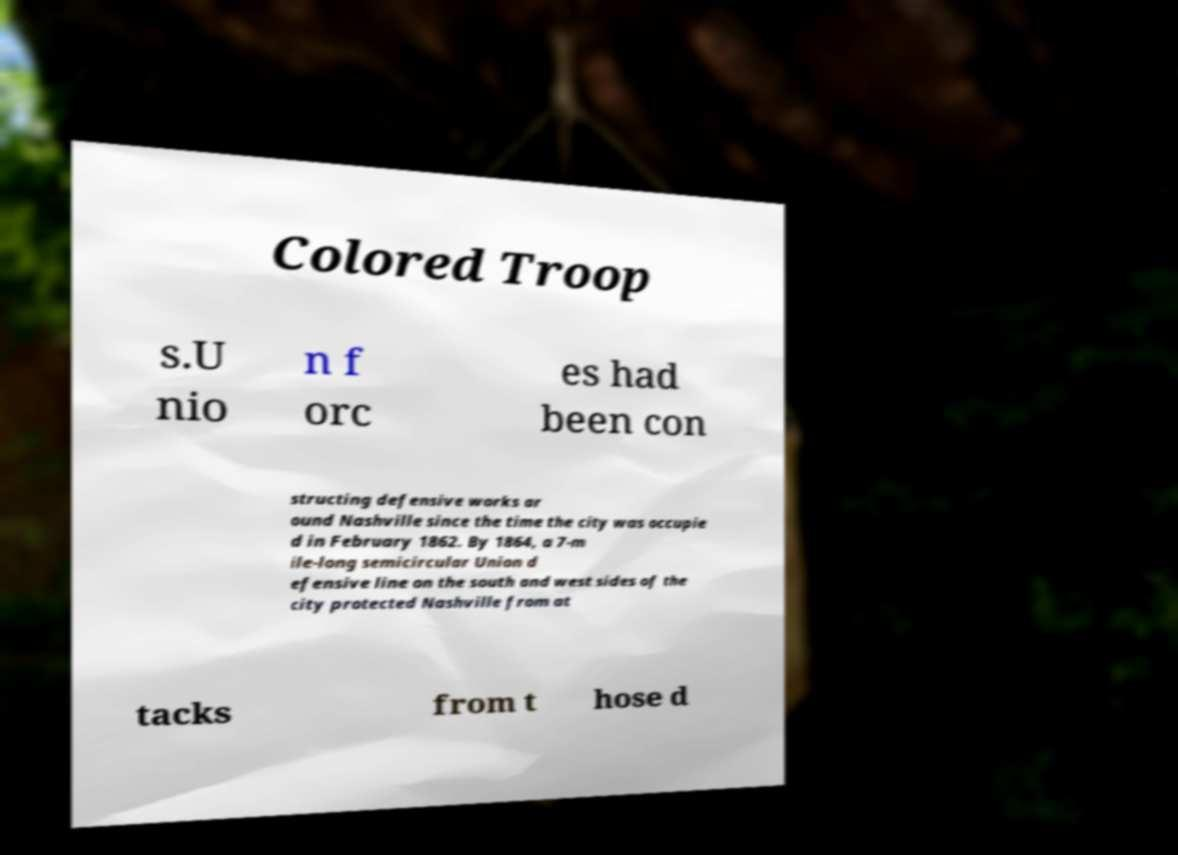Can you read and provide the text displayed in the image?This photo seems to have some interesting text. Can you extract and type it out for me? Colored Troop s.U nio n f orc es had been con structing defensive works ar ound Nashville since the time the city was occupie d in February 1862. By 1864, a 7-m ile-long semicircular Union d efensive line on the south and west sides of the city protected Nashville from at tacks from t hose d 